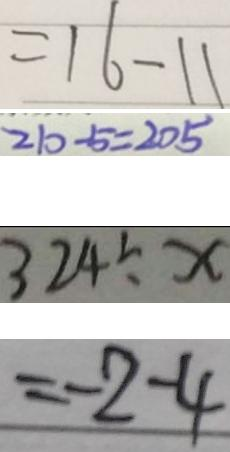Convert formula to latex. <formula><loc_0><loc_0><loc_500><loc_500>= 1 6 - 1 1 
 2 1 0 - 5 = 2 0 4 
 3 2 4 \div x 
 = - 2 - 4</formula> 